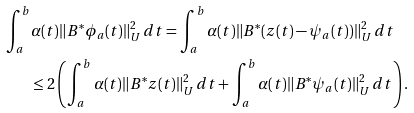Convert formula to latex. <formula><loc_0><loc_0><loc_500><loc_500>\int _ { a } ^ { b } & \alpha ( t ) \| B ^ { * } \phi _ { a } ( t ) \| _ { U } ^ { 2 } \, d t = \int _ { a } ^ { b } \alpha ( t ) \| B ^ { * } ( z ( t ) - \psi _ { a } ( t ) ) \| _ { U } ^ { 2 } \, d t \\ & \leq 2 \left ( \int _ { a } ^ { b } \alpha ( t ) \| B ^ { * } z ( t ) \| _ { U } ^ { 2 } \, d t + \int _ { a } ^ { b } \alpha ( t ) \| B ^ { * } \psi _ { a } ( t ) \| _ { U } ^ { 2 } \, d t \right ) .</formula> 